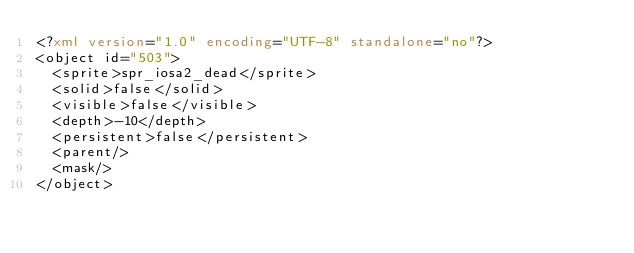Convert code to text. <code><loc_0><loc_0><loc_500><loc_500><_XML_><?xml version="1.0" encoding="UTF-8" standalone="no"?>
<object id="503">
  <sprite>spr_iosa2_dead</sprite>
  <solid>false</solid>
  <visible>false</visible>
  <depth>-10</depth>
  <persistent>false</persistent>
  <parent/>
  <mask/>
</object>
</code> 